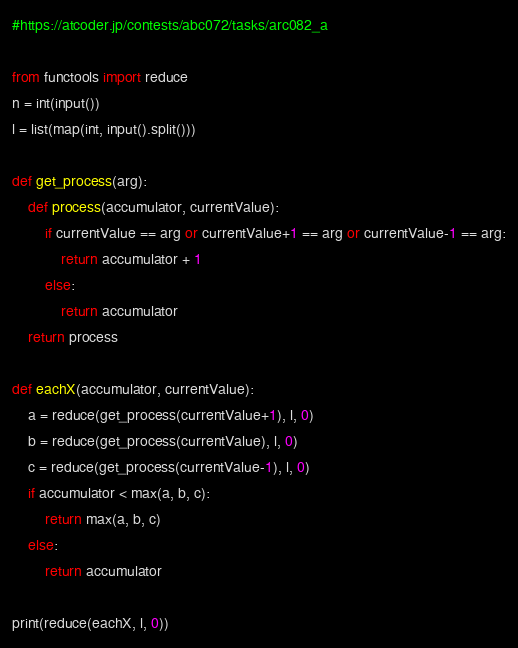<code> <loc_0><loc_0><loc_500><loc_500><_Python_>#https://atcoder.jp/contests/abc072/tasks/arc082_a

from functools import reduce
n = int(input())
l = list(map(int, input().split()))

def get_process(arg):
    def process(accumulator, currentValue):
        if currentValue == arg or currentValue+1 == arg or currentValue-1 == arg:
            return accumulator + 1
        else:
            return accumulator
    return process

def eachX(accumulator, currentValue):
    a = reduce(get_process(currentValue+1), l, 0)
    b = reduce(get_process(currentValue), l, 0)
    c = reduce(get_process(currentValue-1), l, 0)
    if accumulator < max(a, b, c):
        return max(a, b, c)
    else:
        return accumulator

print(reduce(eachX, l, 0))
</code> 